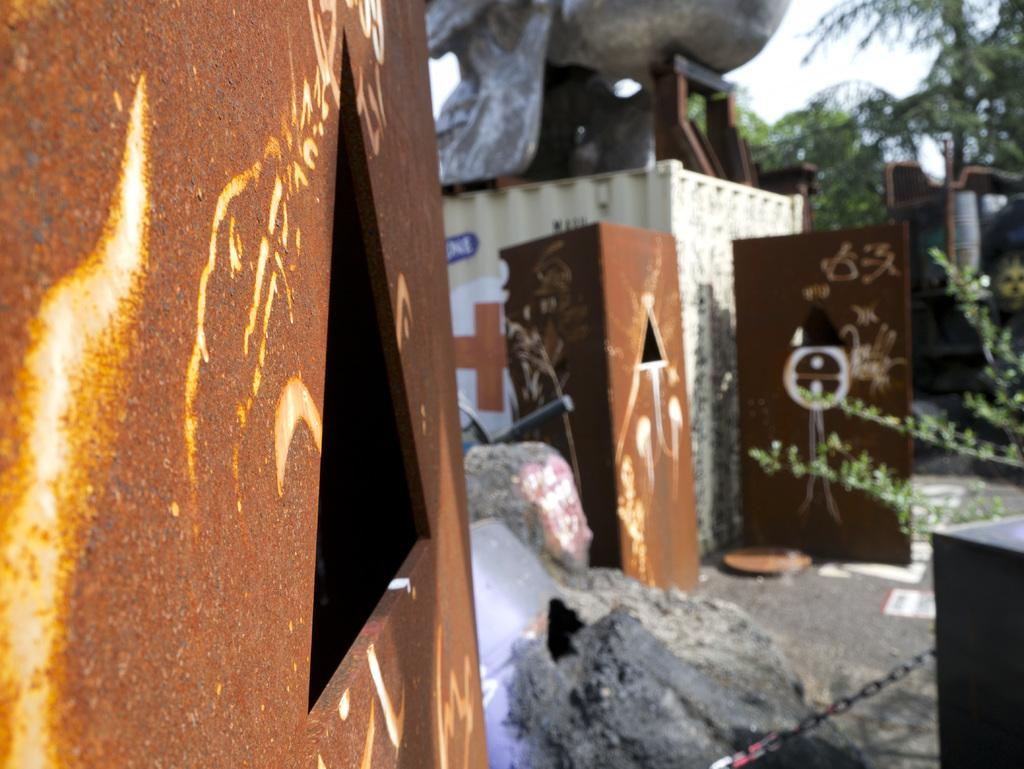What color is the wall that is visible in the image? There is a brown wall in the image. What type of natural elements can be seen in the image? There are rocks and plants in the image. What else can be found in the image besides the wall, rocks, and plants? There are some objects in the image. What type of polish is being applied to the wall in the image? There is no indication in the image that any polish is being applied to the wall. 